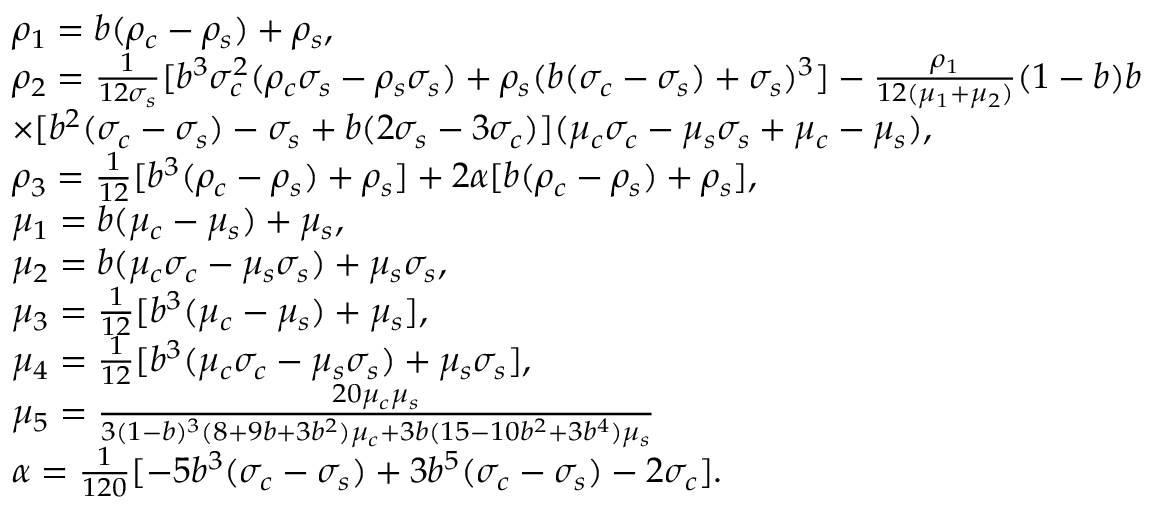<formula> <loc_0><loc_0><loc_500><loc_500>\begin{array} { r l } & { \rho _ { 1 } = b ( \rho _ { c } - \rho _ { s } ) + \rho _ { s } , } \\ & { \rho _ { 2 } = \frac { 1 } { 1 2 \sigma _ { s } } [ b ^ { 3 } \sigma _ { c } ^ { 2 } ( \rho _ { c } \sigma _ { s } - \rho _ { s } \sigma _ { s } ) + \rho _ { s } ( b ( \sigma _ { c } - \sigma _ { s } ) + \sigma _ { s } ) ^ { 3 } ] - \frac { \rho _ { 1 } } { 1 2 ( \mu _ { 1 } + \mu _ { 2 } ) } ( 1 - b ) b } \\ & { \times [ b ^ { 2 } ( \sigma _ { c } - \sigma _ { s } ) - \sigma _ { s } + b ( 2 \sigma _ { s } - 3 \sigma _ { c } ) ] ( \mu _ { c } \sigma _ { c } - \mu _ { s } \sigma _ { s } + \mu _ { c } - \mu _ { s } ) , } \\ & { \rho _ { 3 } = \frac { 1 } { 1 2 } [ b ^ { 3 } ( \rho _ { c } - \rho _ { s } ) + \rho _ { s } ] + 2 \alpha [ b ( \rho _ { c } - \rho _ { s } ) + \rho _ { s } ] , } \\ & { \mu _ { 1 } = b ( \mu _ { c } - \mu _ { s } ) + \mu _ { s } , } \\ & { \mu _ { 2 } = b ( \mu _ { c } \sigma _ { c } - \mu _ { s } \sigma _ { s } ) + \mu _ { s } \sigma _ { s } , } \\ & { \mu _ { 3 } = \frac { 1 } { 1 2 } [ b ^ { 3 } ( \mu _ { c } - \mu _ { s } ) + \mu _ { s } ] , } \\ & { \mu _ { 4 } = \frac { 1 } { 1 2 } [ b ^ { 3 } ( \mu _ { c } \sigma _ { c } - \mu _ { s } \sigma _ { s } ) + \mu _ { s } \sigma _ { s } ] , } \\ & { \mu _ { 5 } = \frac { 2 0 \mu _ { c } \mu _ { s } } { 3 ( 1 - b ) ^ { 3 } ( 8 + 9 b + 3 b ^ { 2 } ) \mu _ { c } + 3 b ( 1 5 - 1 0 b ^ { 2 } + 3 b ^ { 4 } ) \mu _ { s } } } \\ & { \alpha = \frac { 1 } { 1 2 0 } [ - 5 b ^ { 3 } ( \sigma _ { c } - \sigma _ { s } ) + 3 b ^ { 5 } ( \sigma _ { c } - \sigma _ { s } ) - 2 \sigma _ { c } ] . } \end{array}</formula> 